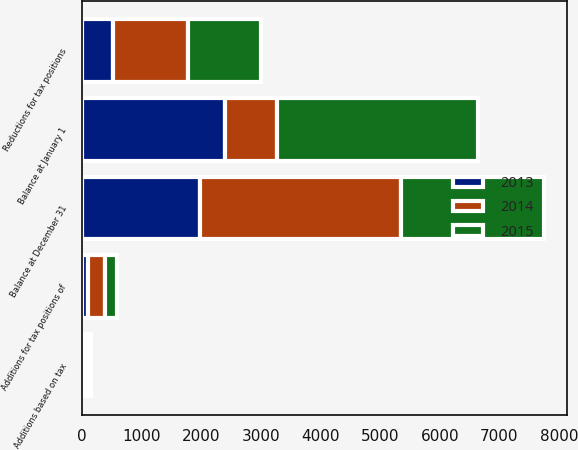Convert chart to OTSL. <chart><loc_0><loc_0><loc_500><loc_500><stacked_bar_chart><ecel><fcel>Balance at January 1<fcel>Additions based on tax<fcel>Additions for tax positions of<fcel>Reductions for tax positions<fcel>Balance at December 31<nl><fcel>2013<fcel>2402<fcel>50<fcel>111<fcel>524<fcel>1982<nl><fcel>2015<fcel>3369<fcel>50<fcel>195<fcel>1212<fcel>2402<nl><fcel>2014<fcel>868<fcel>50<fcel>283<fcel>1260<fcel>3369<nl></chart> 